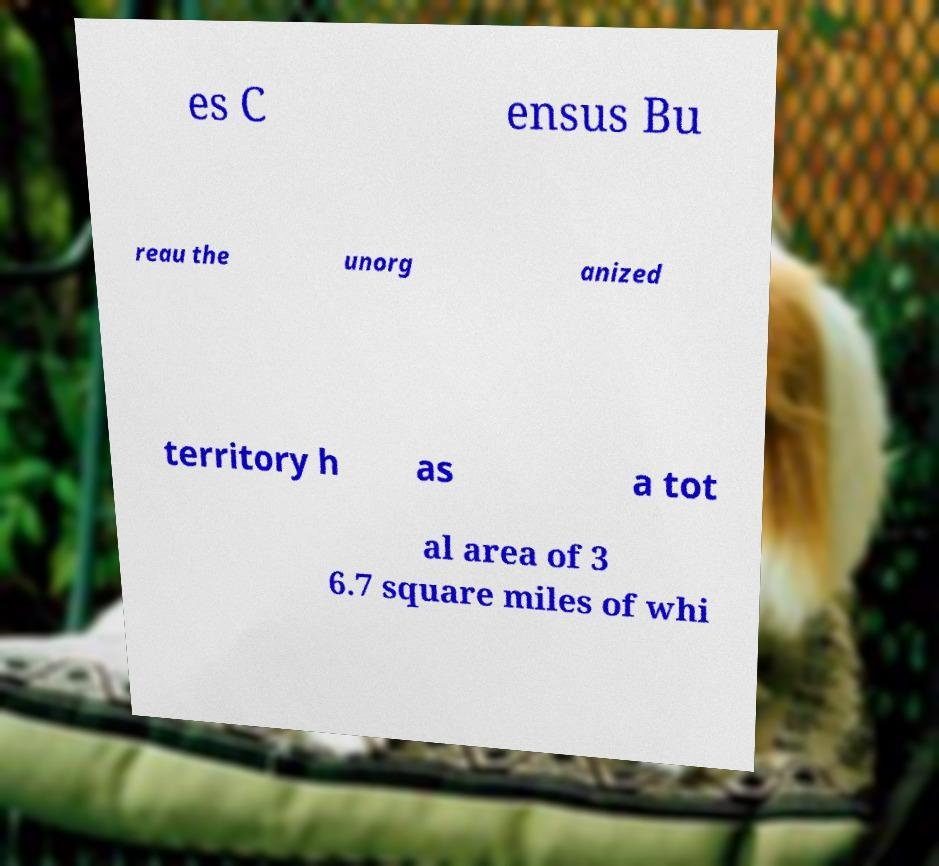There's text embedded in this image that I need extracted. Can you transcribe it verbatim? es C ensus Bu reau the unorg anized territory h as a tot al area of 3 6.7 square miles of whi 